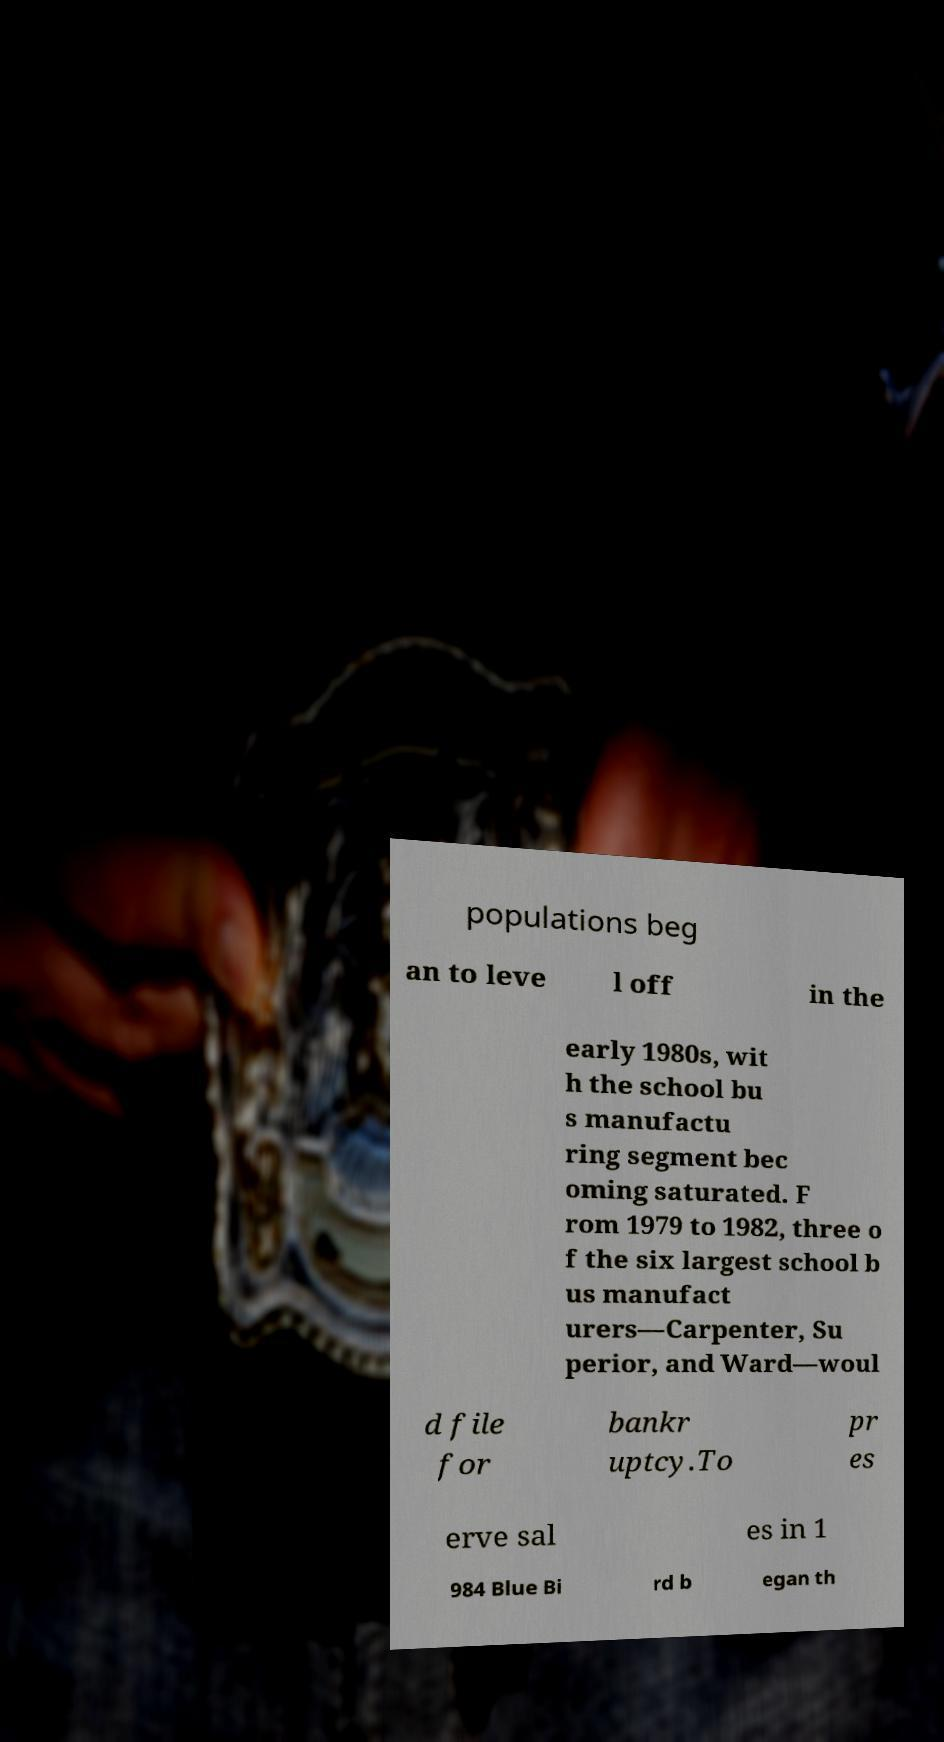What messages or text are displayed in this image? I need them in a readable, typed format. populations beg an to leve l off in the early 1980s, wit h the school bu s manufactu ring segment bec oming saturated. F rom 1979 to 1982, three o f the six largest school b us manufact urers—Carpenter, Su perior, and Ward—woul d file for bankr uptcy.To pr es erve sal es in 1 984 Blue Bi rd b egan th 